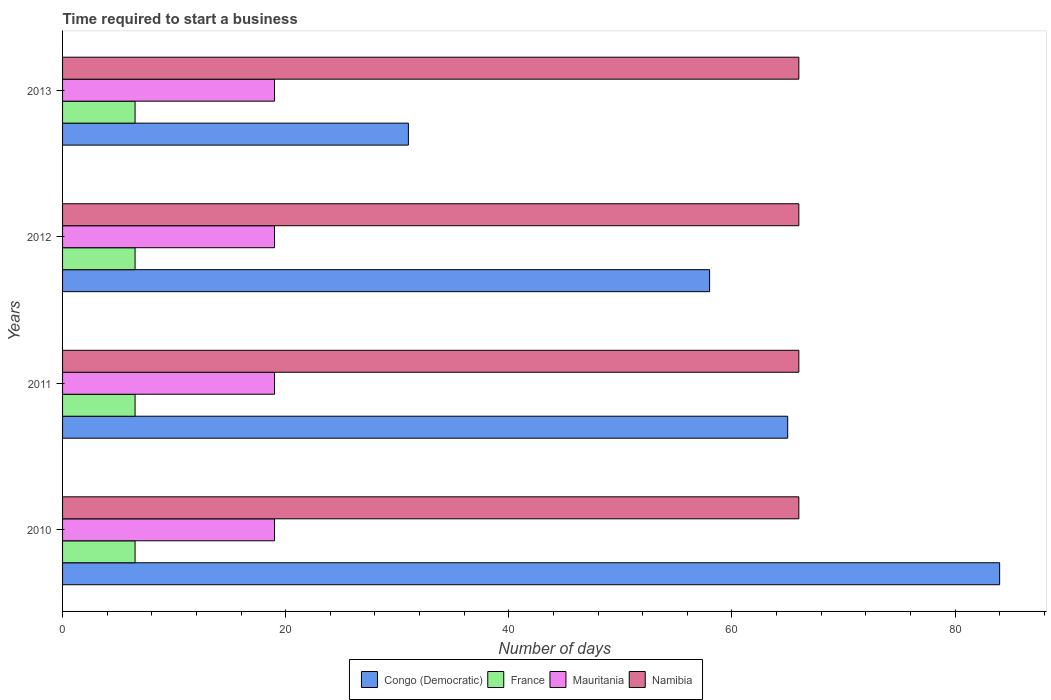How many groups of bars are there?
Offer a very short reply. 4. Are the number of bars per tick equal to the number of legend labels?
Ensure brevity in your answer.  Yes. How many bars are there on the 3rd tick from the top?
Ensure brevity in your answer.  4. In how many cases, is the number of bars for a given year not equal to the number of legend labels?
Your response must be concise. 0. What is the number of days required to start a business in Mauritania in 2012?
Your answer should be very brief. 19. Across all years, what is the maximum number of days required to start a business in Mauritania?
Offer a very short reply. 19. Across all years, what is the minimum number of days required to start a business in Mauritania?
Keep it short and to the point. 19. In which year was the number of days required to start a business in France maximum?
Offer a very short reply. 2010. In which year was the number of days required to start a business in Mauritania minimum?
Provide a succinct answer. 2010. What is the total number of days required to start a business in Congo (Democratic) in the graph?
Your answer should be compact. 238. What is the difference between the number of days required to start a business in Congo (Democratic) in 2012 and that in 2013?
Your answer should be very brief. 27. What is the difference between the number of days required to start a business in France in 2011 and the number of days required to start a business in Congo (Democratic) in 2013?
Ensure brevity in your answer.  -24.5. In the year 2013, what is the difference between the number of days required to start a business in Namibia and number of days required to start a business in Mauritania?
Make the answer very short. 47. What is the ratio of the number of days required to start a business in France in 2010 to that in 2011?
Your answer should be compact. 1. Is the number of days required to start a business in Congo (Democratic) in 2010 less than that in 2013?
Offer a very short reply. No. Is the difference between the number of days required to start a business in Namibia in 2012 and 2013 greater than the difference between the number of days required to start a business in Mauritania in 2012 and 2013?
Provide a short and direct response. No. What is the difference between the highest and the lowest number of days required to start a business in France?
Make the answer very short. 0. In how many years, is the number of days required to start a business in Namibia greater than the average number of days required to start a business in Namibia taken over all years?
Make the answer very short. 0. Is it the case that in every year, the sum of the number of days required to start a business in Mauritania and number of days required to start a business in Congo (Democratic) is greater than the sum of number of days required to start a business in France and number of days required to start a business in Namibia?
Provide a short and direct response. Yes. What does the 3rd bar from the top in 2013 represents?
Your response must be concise. France. What does the 4th bar from the bottom in 2012 represents?
Offer a very short reply. Namibia. How many bars are there?
Ensure brevity in your answer.  16. Are all the bars in the graph horizontal?
Provide a short and direct response. Yes. How many years are there in the graph?
Offer a very short reply. 4. What is the difference between two consecutive major ticks on the X-axis?
Offer a terse response. 20. Does the graph contain grids?
Your answer should be compact. No. How many legend labels are there?
Keep it short and to the point. 4. What is the title of the graph?
Provide a succinct answer. Time required to start a business. What is the label or title of the X-axis?
Make the answer very short. Number of days. What is the Number of days in Mauritania in 2011?
Offer a very short reply. 19. What is the Number of days of Mauritania in 2013?
Offer a terse response. 19. What is the Number of days in Namibia in 2013?
Offer a very short reply. 66. Across all years, what is the maximum Number of days of Congo (Democratic)?
Give a very brief answer. 84. Across all years, what is the maximum Number of days in France?
Ensure brevity in your answer.  6.5. Across all years, what is the maximum Number of days of Namibia?
Make the answer very short. 66. Across all years, what is the minimum Number of days in Namibia?
Your answer should be very brief. 66. What is the total Number of days in Congo (Democratic) in the graph?
Provide a short and direct response. 238. What is the total Number of days of France in the graph?
Provide a succinct answer. 26. What is the total Number of days of Mauritania in the graph?
Offer a terse response. 76. What is the total Number of days in Namibia in the graph?
Provide a short and direct response. 264. What is the difference between the Number of days of France in 2010 and that in 2011?
Provide a short and direct response. 0. What is the difference between the Number of days of Mauritania in 2010 and that in 2011?
Your answer should be very brief. 0. What is the difference between the Number of days of Namibia in 2010 and that in 2011?
Your answer should be very brief. 0. What is the difference between the Number of days of Congo (Democratic) in 2010 and that in 2012?
Your answer should be compact. 26. What is the difference between the Number of days of France in 2010 and that in 2012?
Your answer should be very brief. 0. What is the difference between the Number of days in Namibia in 2010 and that in 2012?
Your answer should be compact. 0. What is the difference between the Number of days of Congo (Democratic) in 2010 and that in 2013?
Your answer should be compact. 53. What is the difference between the Number of days of Mauritania in 2010 and that in 2013?
Give a very brief answer. 0. What is the difference between the Number of days in Namibia in 2010 and that in 2013?
Ensure brevity in your answer.  0. What is the difference between the Number of days of Namibia in 2011 and that in 2012?
Your answer should be compact. 0. What is the difference between the Number of days of Congo (Democratic) in 2011 and that in 2013?
Offer a terse response. 34. What is the difference between the Number of days of Mauritania in 2011 and that in 2013?
Make the answer very short. 0. What is the difference between the Number of days in Congo (Democratic) in 2012 and that in 2013?
Provide a succinct answer. 27. What is the difference between the Number of days in France in 2012 and that in 2013?
Make the answer very short. 0. What is the difference between the Number of days of Namibia in 2012 and that in 2013?
Offer a very short reply. 0. What is the difference between the Number of days in Congo (Democratic) in 2010 and the Number of days in France in 2011?
Provide a succinct answer. 77.5. What is the difference between the Number of days of France in 2010 and the Number of days of Mauritania in 2011?
Your answer should be very brief. -12.5. What is the difference between the Number of days of France in 2010 and the Number of days of Namibia in 2011?
Your answer should be compact. -59.5. What is the difference between the Number of days of Mauritania in 2010 and the Number of days of Namibia in 2011?
Provide a short and direct response. -47. What is the difference between the Number of days of Congo (Democratic) in 2010 and the Number of days of France in 2012?
Give a very brief answer. 77.5. What is the difference between the Number of days in Congo (Democratic) in 2010 and the Number of days in Mauritania in 2012?
Your response must be concise. 65. What is the difference between the Number of days of France in 2010 and the Number of days of Namibia in 2012?
Offer a very short reply. -59.5. What is the difference between the Number of days in Mauritania in 2010 and the Number of days in Namibia in 2012?
Your answer should be very brief. -47. What is the difference between the Number of days of Congo (Democratic) in 2010 and the Number of days of France in 2013?
Make the answer very short. 77.5. What is the difference between the Number of days in France in 2010 and the Number of days in Namibia in 2013?
Offer a terse response. -59.5. What is the difference between the Number of days in Mauritania in 2010 and the Number of days in Namibia in 2013?
Keep it short and to the point. -47. What is the difference between the Number of days in Congo (Democratic) in 2011 and the Number of days in France in 2012?
Your answer should be compact. 58.5. What is the difference between the Number of days of France in 2011 and the Number of days of Mauritania in 2012?
Offer a terse response. -12.5. What is the difference between the Number of days of France in 2011 and the Number of days of Namibia in 2012?
Your answer should be very brief. -59.5. What is the difference between the Number of days in Mauritania in 2011 and the Number of days in Namibia in 2012?
Your answer should be very brief. -47. What is the difference between the Number of days in Congo (Democratic) in 2011 and the Number of days in France in 2013?
Provide a short and direct response. 58.5. What is the difference between the Number of days of Congo (Democratic) in 2011 and the Number of days of Namibia in 2013?
Offer a very short reply. -1. What is the difference between the Number of days of France in 2011 and the Number of days of Mauritania in 2013?
Ensure brevity in your answer.  -12.5. What is the difference between the Number of days of France in 2011 and the Number of days of Namibia in 2013?
Give a very brief answer. -59.5. What is the difference between the Number of days in Mauritania in 2011 and the Number of days in Namibia in 2013?
Provide a short and direct response. -47. What is the difference between the Number of days of Congo (Democratic) in 2012 and the Number of days of France in 2013?
Your answer should be very brief. 51.5. What is the difference between the Number of days in France in 2012 and the Number of days in Mauritania in 2013?
Provide a succinct answer. -12.5. What is the difference between the Number of days in France in 2012 and the Number of days in Namibia in 2013?
Your response must be concise. -59.5. What is the difference between the Number of days of Mauritania in 2012 and the Number of days of Namibia in 2013?
Your answer should be compact. -47. What is the average Number of days in Congo (Democratic) per year?
Make the answer very short. 59.5. What is the average Number of days in Mauritania per year?
Provide a short and direct response. 19. What is the average Number of days of Namibia per year?
Offer a terse response. 66. In the year 2010, what is the difference between the Number of days of Congo (Democratic) and Number of days of France?
Offer a terse response. 77.5. In the year 2010, what is the difference between the Number of days in France and Number of days in Namibia?
Your response must be concise. -59.5. In the year 2010, what is the difference between the Number of days in Mauritania and Number of days in Namibia?
Provide a succinct answer. -47. In the year 2011, what is the difference between the Number of days of Congo (Democratic) and Number of days of France?
Your answer should be very brief. 58.5. In the year 2011, what is the difference between the Number of days of Congo (Democratic) and Number of days of Mauritania?
Your answer should be very brief. 46. In the year 2011, what is the difference between the Number of days in France and Number of days in Namibia?
Your response must be concise. -59.5. In the year 2011, what is the difference between the Number of days in Mauritania and Number of days in Namibia?
Your answer should be compact. -47. In the year 2012, what is the difference between the Number of days in Congo (Democratic) and Number of days in France?
Provide a succinct answer. 51.5. In the year 2012, what is the difference between the Number of days of Congo (Democratic) and Number of days of Mauritania?
Give a very brief answer. 39. In the year 2012, what is the difference between the Number of days of Congo (Democratic) and Number of days of Namibia?
Offer a very short reply. -8. In the year 2012, what is the difference between the Number of days of France and Number of days of Mauritania?
Provide a short and direct response. -12.5. In the year 2012, what is the difference between the Number of days in France and Number of days in Namibia?
Your response must be concise. -59.5. In the year 2012, what is the difference between the Number of days of Mauritania and Number of days of Namibia?
Offer a very short reply. -47. In the year 2013, what is the difference between the Number of days in Congo (Democratic) and Number of days in Namibia?
Ensure brevity in your answer.  -35. In the year 2013, what is the difference between the Number of days in France and Number of days in Mauritania?
Provide a succinct answer. -12.5. In the year 2013, what is the difference between the Number of days in France and Number of days in Namibia?
Provide a succinct answer. -59.5. In the year 2013, what is the difference between the Number of days of Mauritania and Number of days of Namibia?
Keep it short and to the point. -47. What is the ratio of the Number of days in Congo (Democratic) in 2010 to that in 2011?
Provide a short and direct response. 1.29. What is the ratio of the Number of days in France in 2010 to that in 2011?
Ensure brevity in your answer.  1. What is the ratio of the Number of days of Congo (Democratic) in 2010 to that in 2012?
Provide a short and direct response. 1.45. What is the ratio of the Number of days of Namibia in 2010 to that in 2012?
Make the answer very short. 1. What is the ratio of the Number of days in Congo (Democratic) in 2010 to that in 2013?
Offer a terse response. 2.71. What is the ratio of the Number of days of France in 2010 to that in 2013?
Ensure brevity in your answer.  1. What is the ratio of the Number of days of Mauritania in 2010 to that in 2013?
Your answer should be compact. 1. What is the ratio of the Number of days in Namibia in 2010 to that in 2013?
Ensure brevity in your answer.  1. What is the ratio of the Number of days in Congo (Democratic) in 2011 to that in 2012?
Offer a very short reply. 1.12. What is the ratio of the Number of days of Congo (Democratic) in 2011 to that in 2013?
Your answer should be compact. 2.1. What is the ratio of the Number of days of France in 2011 to that in 2013?
Offer a very short reply. 1. What is the ratio of the Number of days in Mauritania in 2011 to that in 2013?
Give a very brief answer. 1. What is the ratio of the Number of days in Congo (Democratic) in 2012 to that in 2013?
Provide a short and direct response. 1.87. What is the difference between the highest and the second highest Number of days in Congo (Democratic)?
Your answer should be very brief. 19. What is the difference between the highest and the second highest Number of days of Mauritania?
Your response must be concise. 0. What is the difference between the highest and the lowest Number of days of France?
Your response must be concise. 0. 